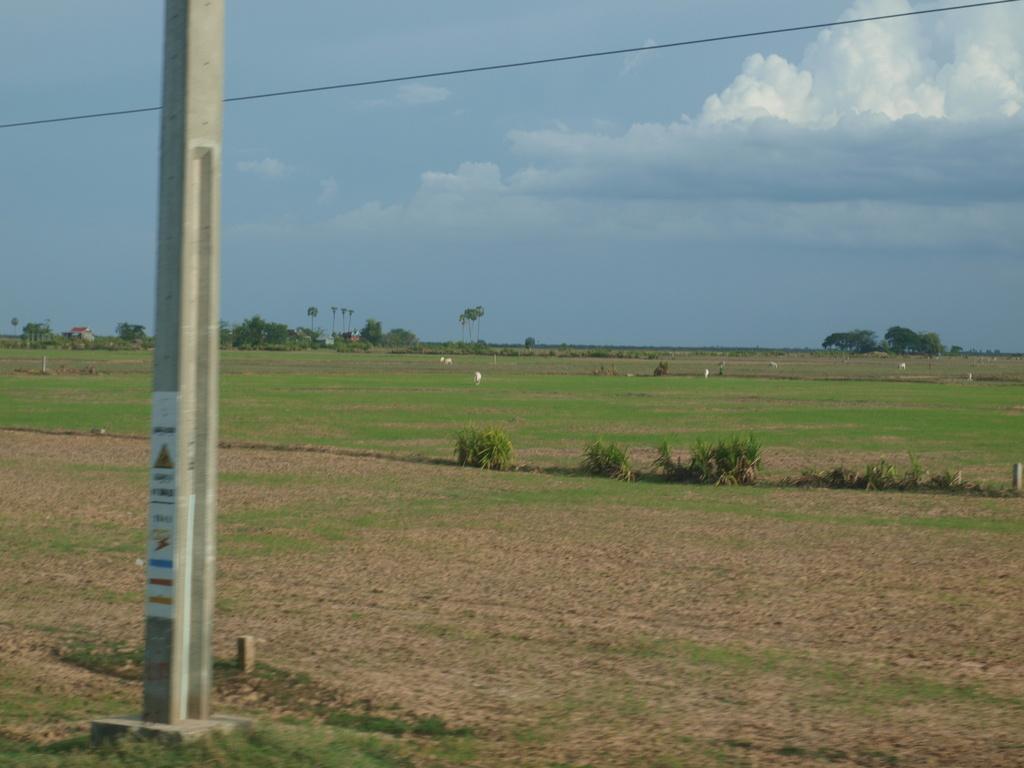Please provide a concise description of this image. In this image there is a pole on the land having some grass and plants. There are animals on the land. Background there are trees. Top of the image there is sky with some clouds. 